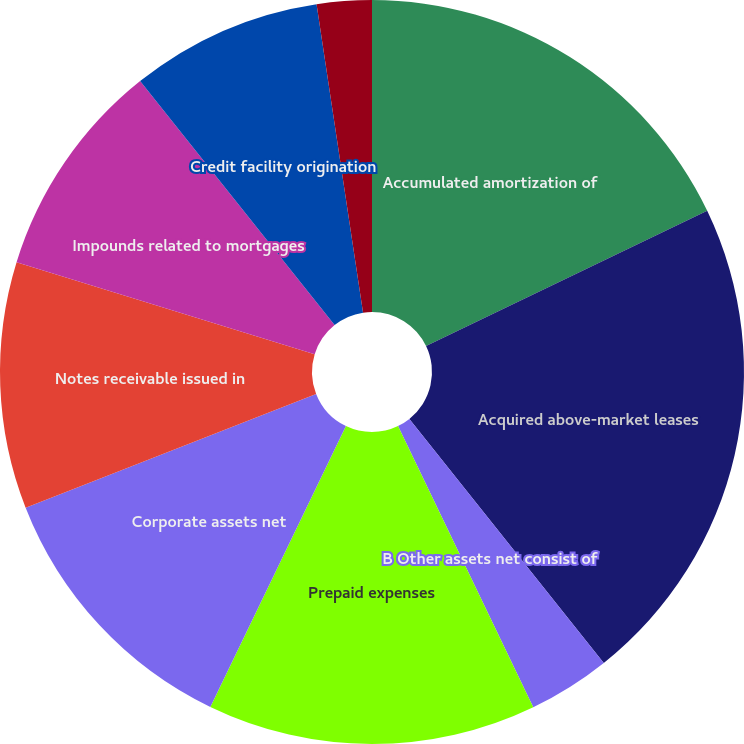Convert chart to OTSL. <chart><loc_0><loc_0><loc_500><loc_500><pie_chart><fcel>Accumulated amortization of<fcel>Acquired above-market leases<fcel>B Other assets net consist of<fcel>Prepaid expenses<fcel>Corporate assets net<fcel>Notes receivable issued in<fcel>Impounds related to mortgages<fcel>Credit facility origination<fcel>Restricted escrow deposits<nl><fcel>17.86%<fcel>21.43%<fcel>3.57%<fcel>14.29%<fcel>11.9%<fcel>10.71%<fcel>9.52%<fcel>8.33%<fcel>2.38%<nl></chart> 